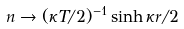<formula> <loc_0><loc_0><loc_500><loc_500>n \rightarrow ( \kappa T / 2 ) ^ { - 1 } \sinh \kappa r / 2</formula> 